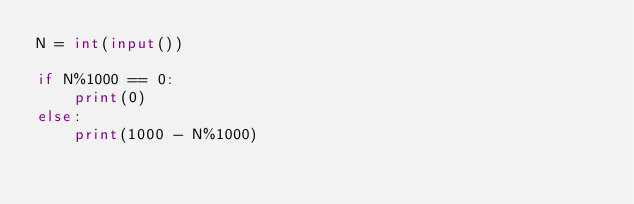<code> <loc_0><loc_0><loc_500><loc_500><_Python_>N = int(input())

if N%1000 == 0:
    print(0)
else:
    print(1000 - N%1000)</code> 